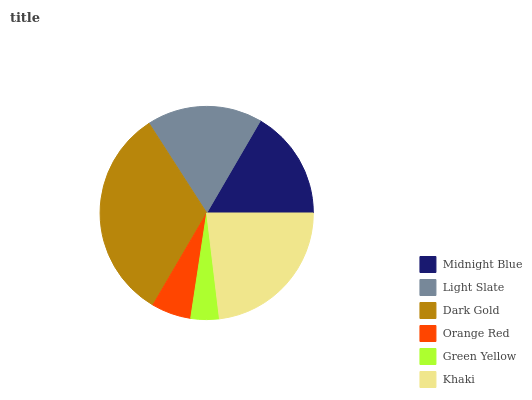Is Green Yellow the minimum?
Answer yes or no. Yes. Is Dark Gold the maximum?
Answer yes or no. Yes. Is Light Slate the minimum?
Answer yes or no. No. Is Light Slate the maximum?
Answer yes or no. No. Is Light Slate greater than Midnight Blue?
Answer yes or no. Yes. Is Midnight Blue less than Light Slate?
Answer yes or no. Yes. Is Midnight Blue greater than Light Slate?
Answer yes or no. No. Is Light Slate less than Midnight Blue?
Answer yes or no. No. Is Light Slate the high median?
Answer yes or no. Yes. Is Midnight Blue the low median?
Answer yes or no. Yes. Is Khaki the high median?
Answer yes or no. No. Is Dark Gold the low median?
Answer yes or no. No. 